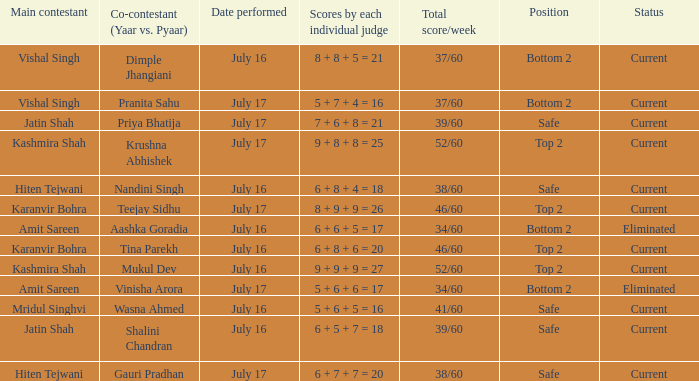What date did Jatin Shah and Shalini Chandran perform? July 16. 